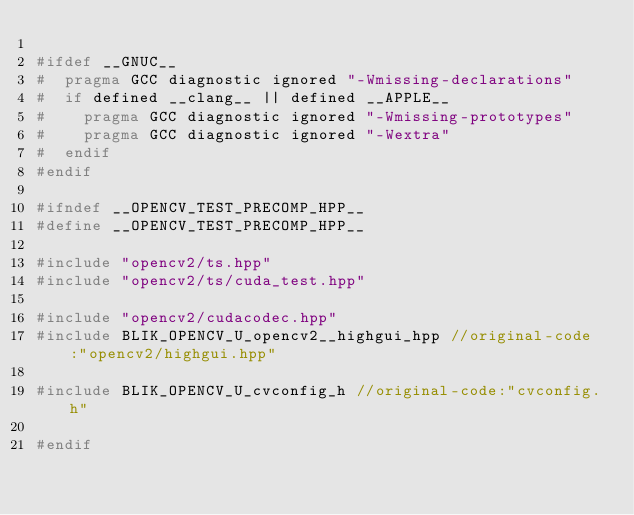Convert code to text. <code><loc_0><loc_0><loc_500><loc_500><_C++_>
#ifdef __GNUC__
#  pragma GCC diagnostic ignored "-Wmissing-declarations"
#  if defined __clang__ || defined __APPLE__
#    pragma GCC diagnostic ignored "-Wmissing-prototypes"
#    pragma GCC diagnostic ignored "-Wextra"
#  endif
#endif

#ifndef __OPENCV_TEST_PRECOMP_HPP__
#define __OPENCV_TEST_PRECOMP_HPP__

#include "opencv2/ts.hpp"
#include "opencv2/ts/cuda_test.hpp"

#include "opencv2/cudacodec.hpp"
#include BLIK_OPENCV_U_opencv2__highgui_hpp //original-code:"opencv2/highgui.hpp"

#include BLIK_OPENCV_U_cvconfig_h //original-code:"cvconfig.h"

#endif
</code> 